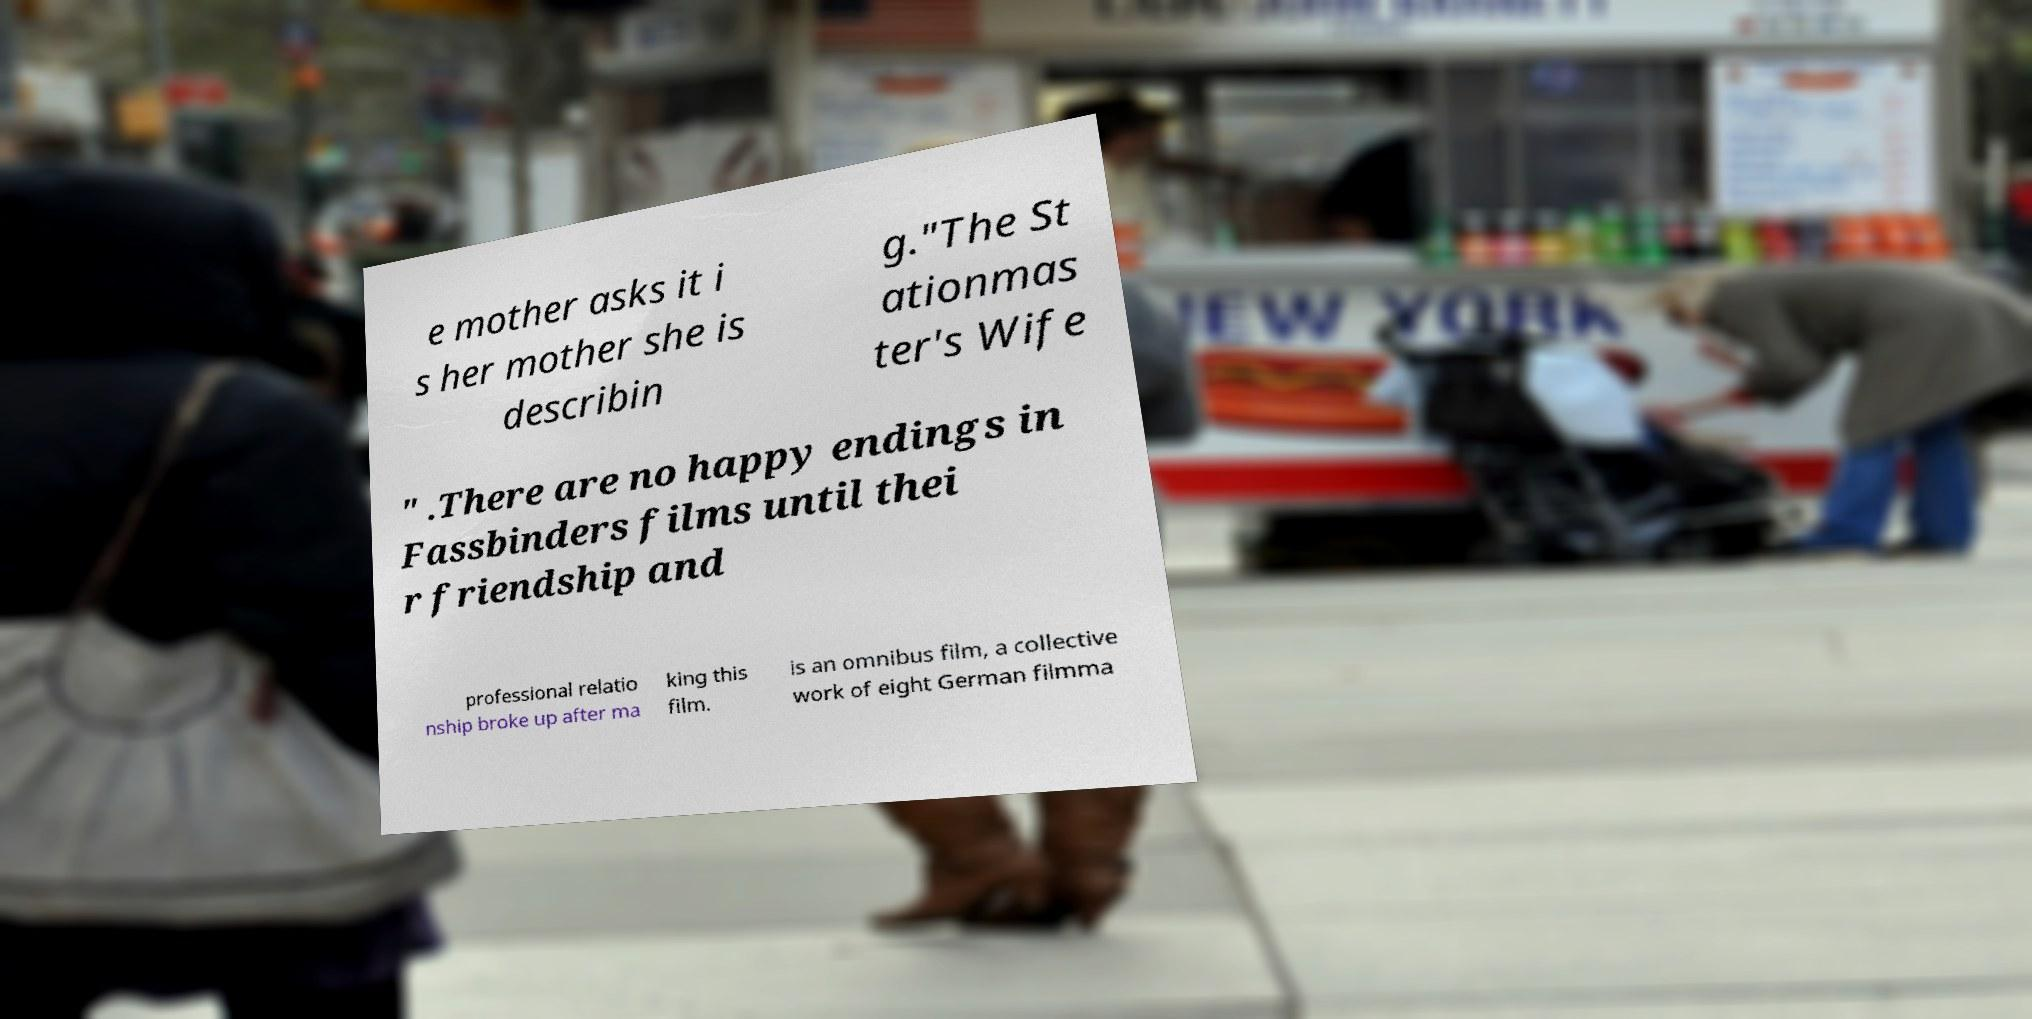I need the written content from this picture converted into text. Can you do that? e mother asks it i s her mother she is describin g."The St ationmas ter's Wife " .There are no happy endings in Fassbinders films until thei r friendship and professional relatio nship broke up after ma king this film. is an omnibus film, a collective work of eight German filmma 